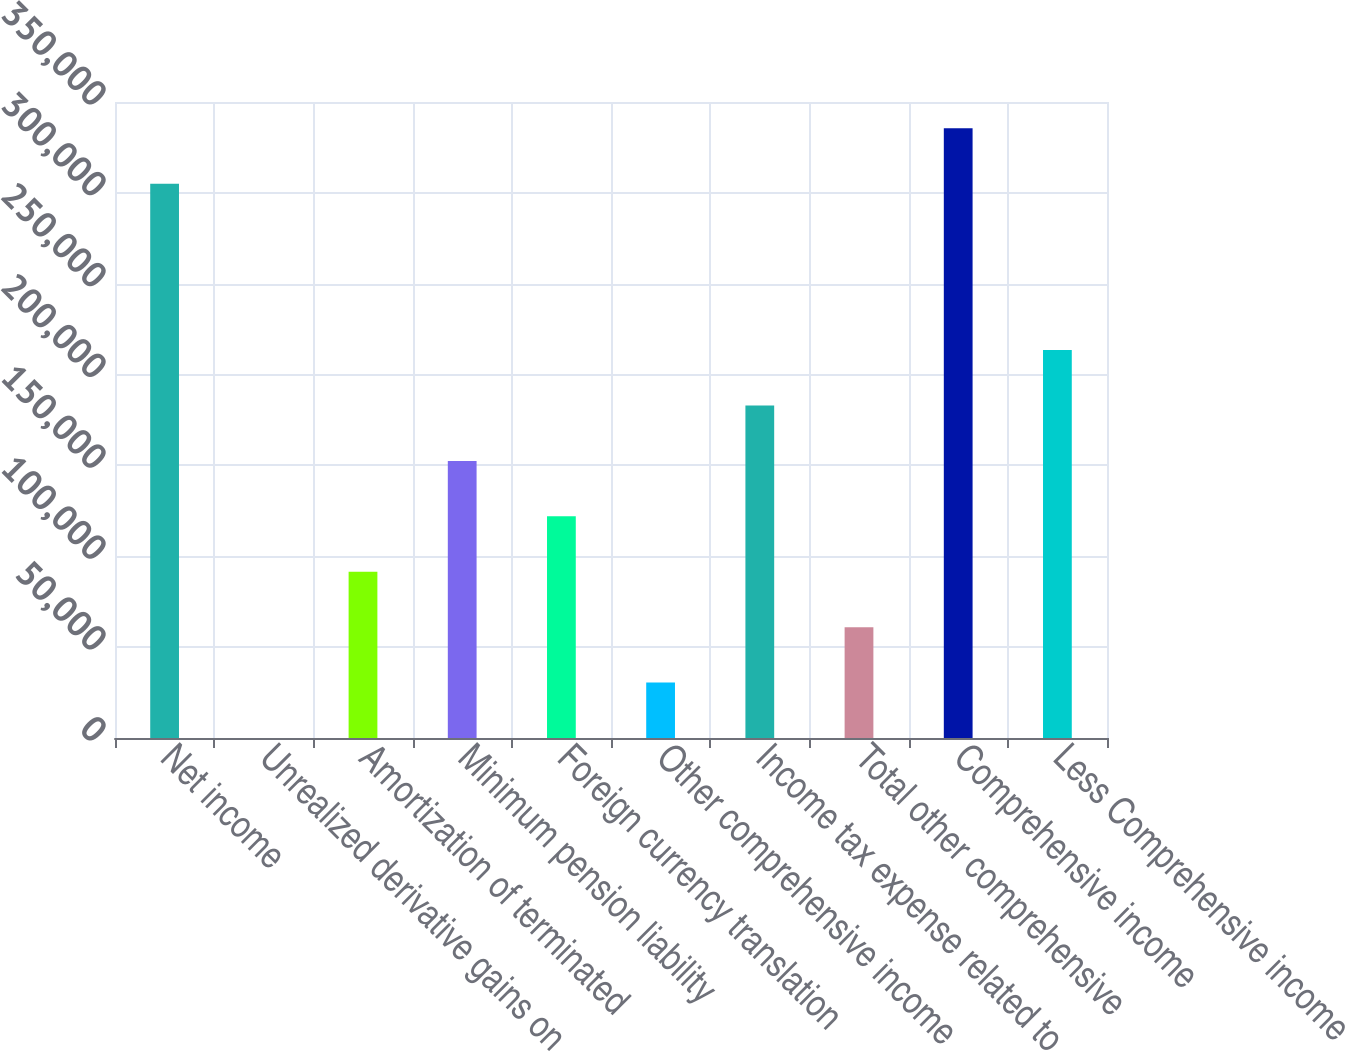<chart> <loc_0><loc_0><loc_500><loc_500><bar_chart><fcel>Net income<fcel>Unrealized derivative gains on<fcel>Amortization of terminated<fcel>Minimum pension liability<fcel>Foreign currency translation<fcel>Other comprehensive income<fcel>Income tax expense related to<fcel>Total other comprehensive<fcel>Comprehensive income<fcel>Less Comprehensive income<nl><fcel>304995<fcel>0.29<fcel>91498.7<fcel>152498<fcel>121998<fcel>30499.8<fcel>182997<fcel>60999.2<fcel>335494<fcel>213497<nl></chart> 